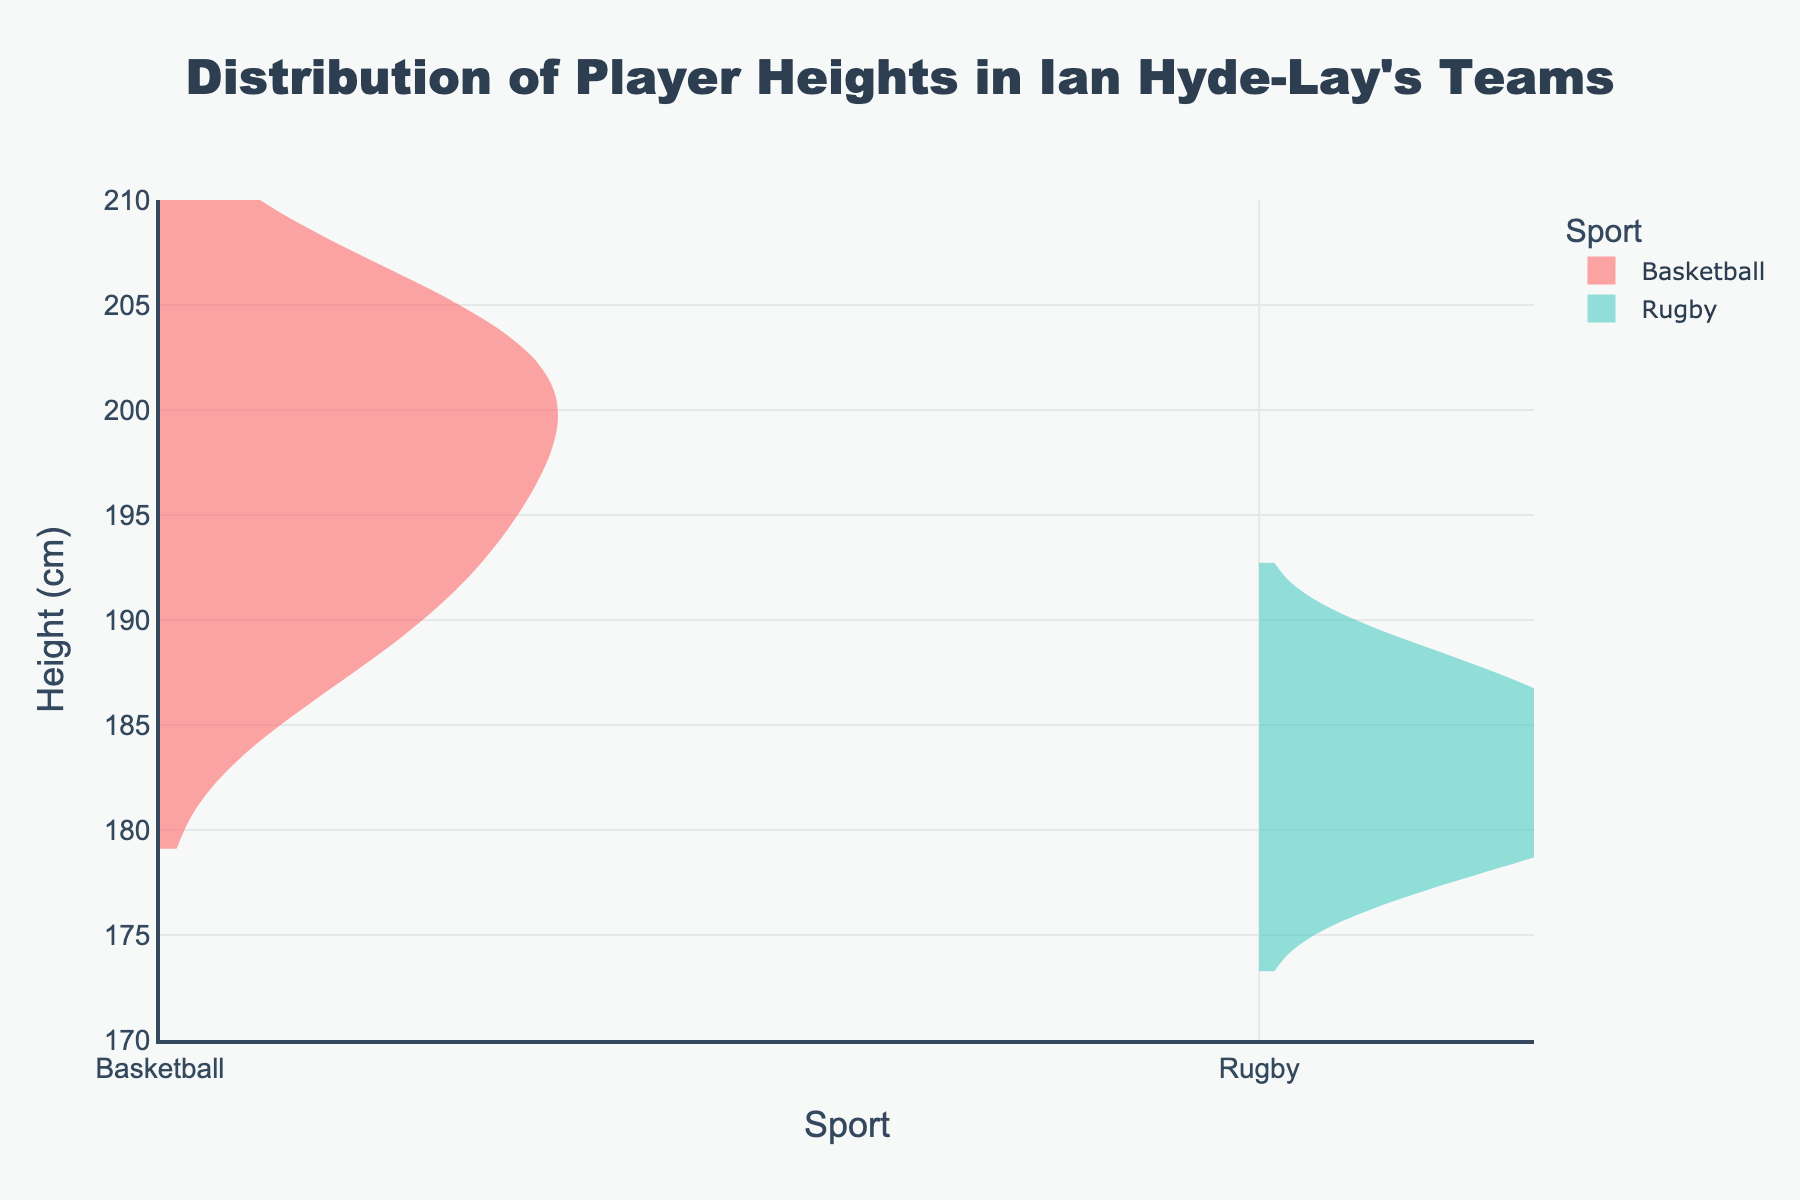What is the title of the figure? The title is located at the top of the figure and provides a brief description of what the figure represents. In this case, it describes the distribution of player heights for basketball and rugby teams.
Answer: Distribution of Player Heights in Ian Hyde-Lay's Teams What is the range of heights shown on the vertical axis? The vertical axis represents the height in centimeters. By looking at the ticks on this axis, we can identify its minimum and maximum values.
Answer: 170 to 210 cm Which sport has a wider spread of player heights? By examining the density plots for both sports, we can observe how spread out the data points are. The sport with a density plot covering a wider range has a greater spread of player heights.
Answer: Basketball What are the peak height ranges for basketball and rugby players? The peak height ranges can be identified by looking at where the density plots are the highest, which indicates the heights where most players are concentrated.
Answer: Basketball: around 200 cm, Rugby: around 183-188 cm How does the median height for basketball players compare to that of rugby players? To find the median height, look at the middle point of each density plot. The median height is where the plot is balanced on either side.
Answer: Basketball median height is higher than Rugby Is there any overlap in height between basketball and rugby players? Overlap is indicated by the intersecting parts of the density plots. If there are intersecting areas, it means players from both sports share similar heights in those ranges.
Answer: Yes On average, which sport tends to have taller players? By comparing the general height ranges and density peaks of both sports, we can conclude which sport has taller players on average.
Answer: Basketball Do any rugby players reach the maximum height range of basketball players? Check the farthest right endpoint of the rugby density plot and compare it to the maximum value on the basketball density plot. The rugby plot should be within the basketball plot's range to confirm.
Answer: No Which sport seems to have a more consistent height distribution among its players? Consistency can be inferred from the density plot shape. A sport with a more uniform density plot indicates a consistent height distribution.
Answer: Rugby How does the height distribution for rugby players compare to that for basketball players below 190 cm? Compare the density plots below the 190 cm mark to see which sport has more density (i.e., more players) in that height range.
Answer: Rugby has more density below 190 cm 